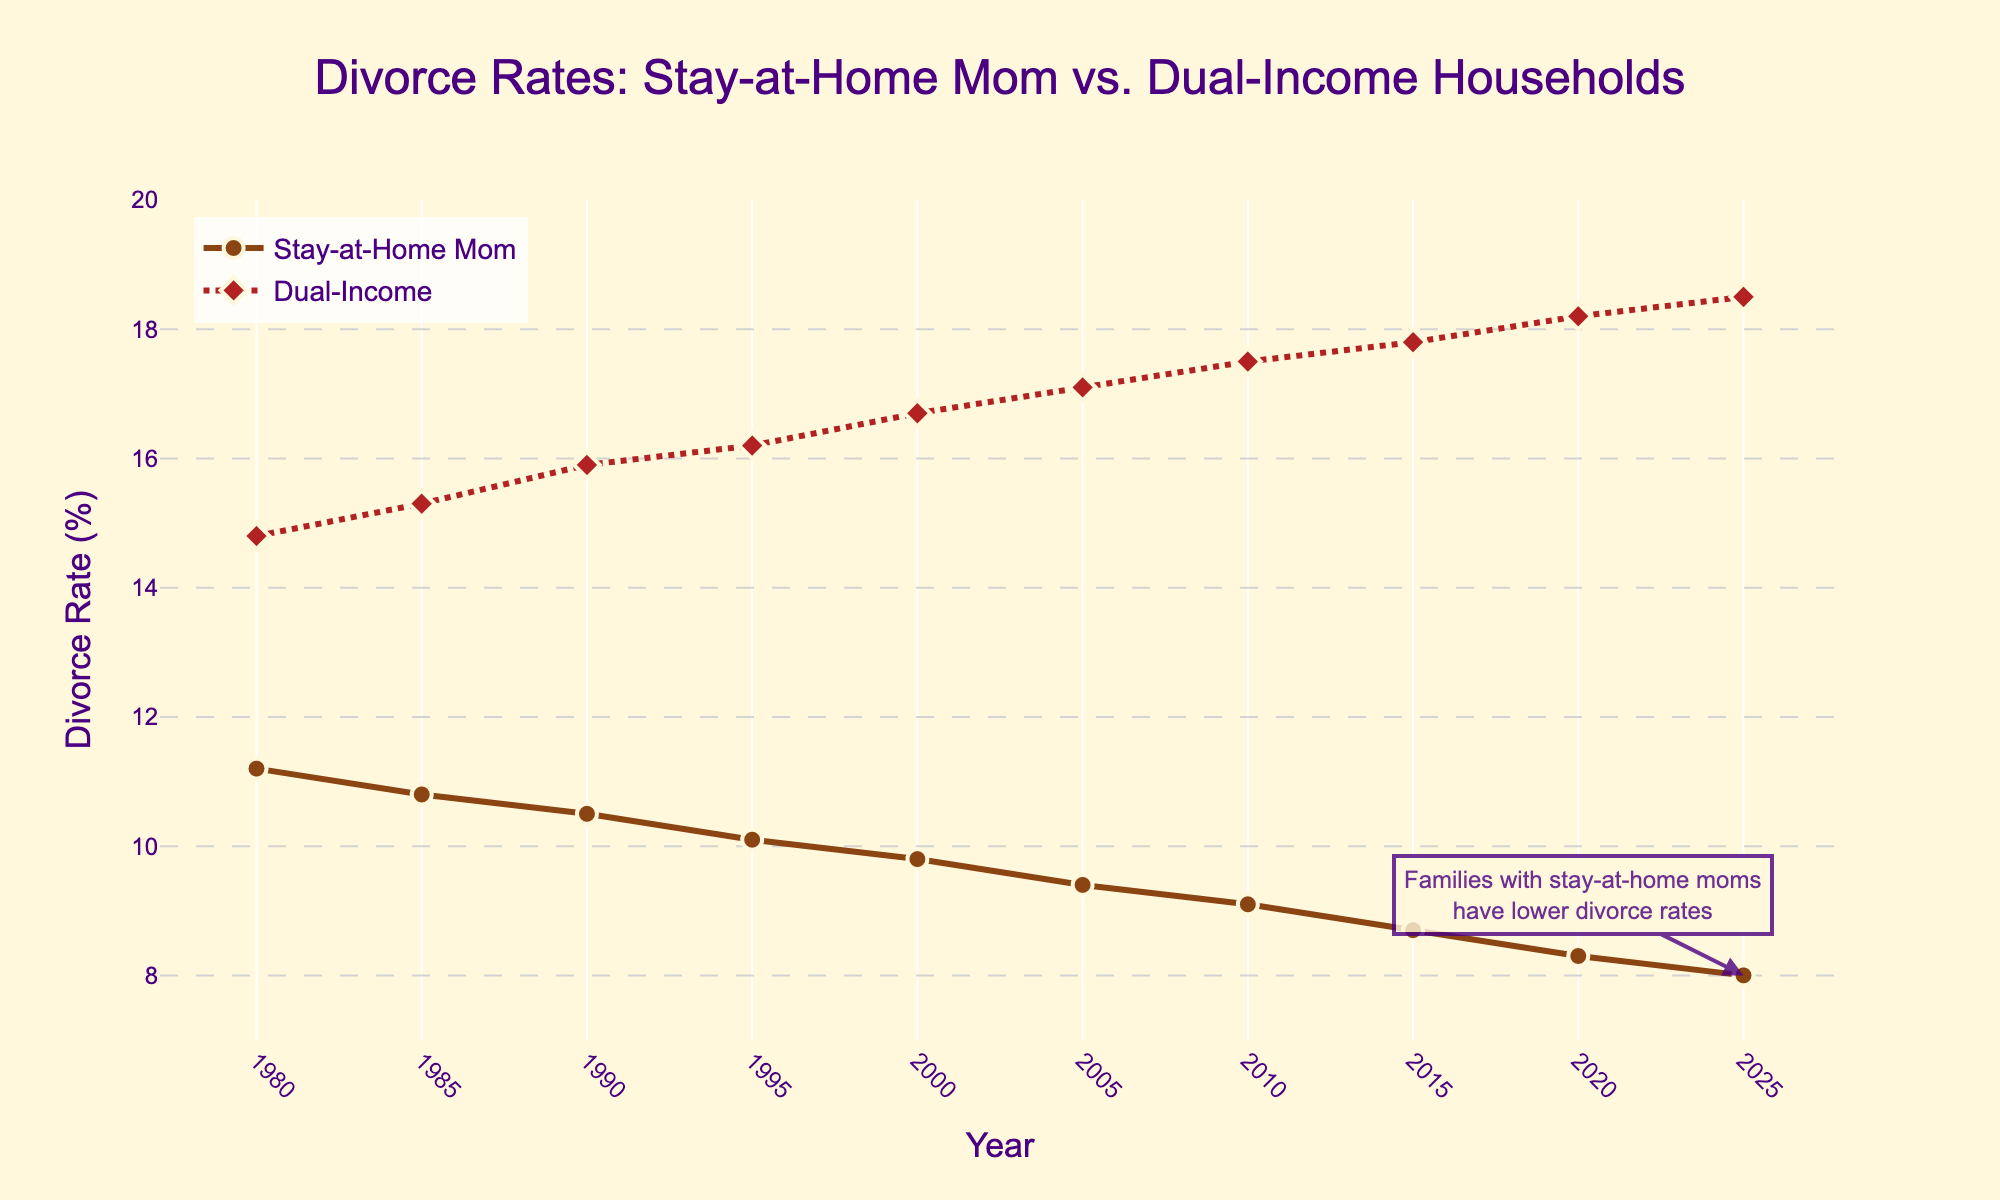Which year shows the lowest divorce rate for stay-at-home mom households? Look at the minimum point on the "Stay-at-Home Mom" line (in brown color) and identify the year. The lowest point is at 2025.
Answer: 2025 How many percentage points higher was the divorce rate in dual-income households compared to stay-at-home mom households in the year 2000? Find the divorce rates for both categories in 2000 and subtract the stay-at-home mom rate from the dual-income rate. (16.7 - 9.8)
Answer: 6.9 Which group had a higher divorce rate in 2015, and by how much? Compare the divorce rates for both groups in 2015 by looking at the data points. The dual-income households have a rate of 17.8, while stay-at-home moms have 8.7. The difference is (17.8 - 8.7).
Answer: Dual-income, 9.1 Between 1980 and 2025, which group had a general trend of increasing divorce rates? Observe the direction of the lines from 1980 to 2025. The dual-income line shows an increasing trend over the period.
Answer: Dual-income households What is the average divorce rate for stay-at-home mom households from 1980 to 2025? Sum the divorce rates for stay-at-home mom households from each year and divide by the number of years (11.2, 10.8, 10.5, 10.1, 9.8, 9.4, 9.1, 8.7, 8.3, 8.0). The sum is 96.8, and there are 10 years.
Answer: 9.68% In which year did the divorce rate for dual-income households first exceed 15%? Identify the first year where the divorce rate in the red dashed line surpasses 15%. This first occurs in 1985.
Answer: 1985 How much did the divorce rate for stay-at-home mom households decrease from 1980 to 2025? Subtract the 2025 rate from the 1980 rate (11.2 - 8.0). The result is the decrease in percentage points.
Answer: 3.2 In 2020, by what multiple is the divorce rate for dual-income households higher than for stay-at-home mom households? Divide the dual-income rate by the stay-at-home mom rate for 2020 (18.2 / 8.3). This gives the multiple.
Answer: About 2.19 Do stay-at-home mom households or dual-income households show a more rapid decline in divorce rates from 1980 to 2025? Compare the slopes of the lines for the two groups. The stay-at-home mom line has a more substantial downward slope, showing a more rapid decline.
Answer: Stay-at-home mom households By how many percentage points did the divorce rate for stay-at-home mom households change between 1990 and 2010? Subtract the 2010 rate from the 1990 rate for stay-at-home mom households (10.5 - 9.1).
Answer: 1.4 